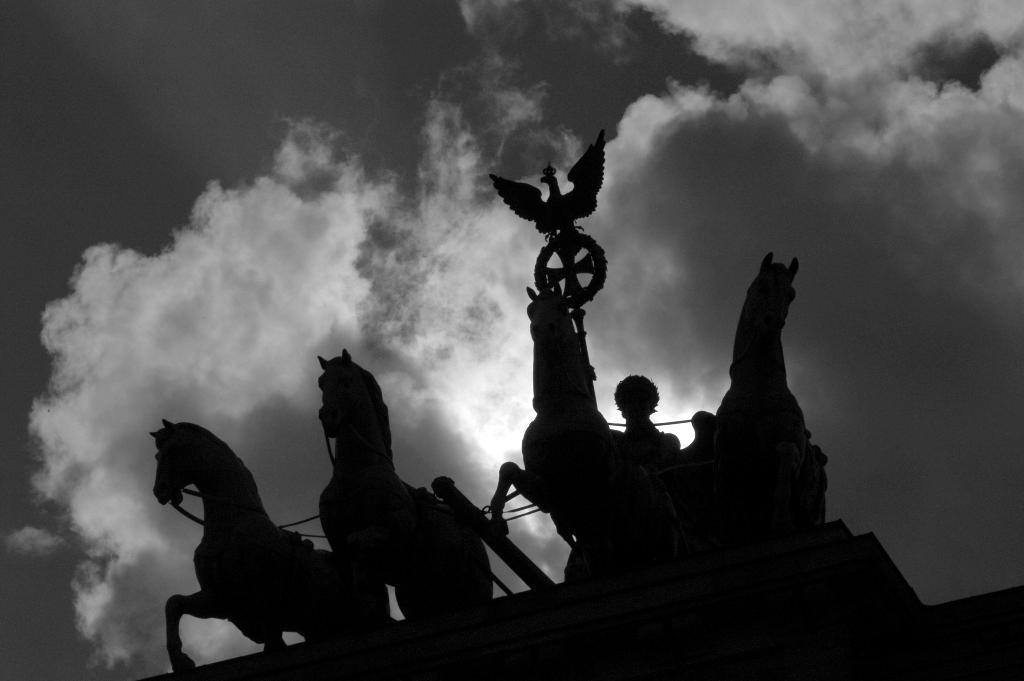Can you describe this image briefly? In this image I can see few sculptures in the front and in the background I can see clouds. I can also see this image is black and white in colour. 